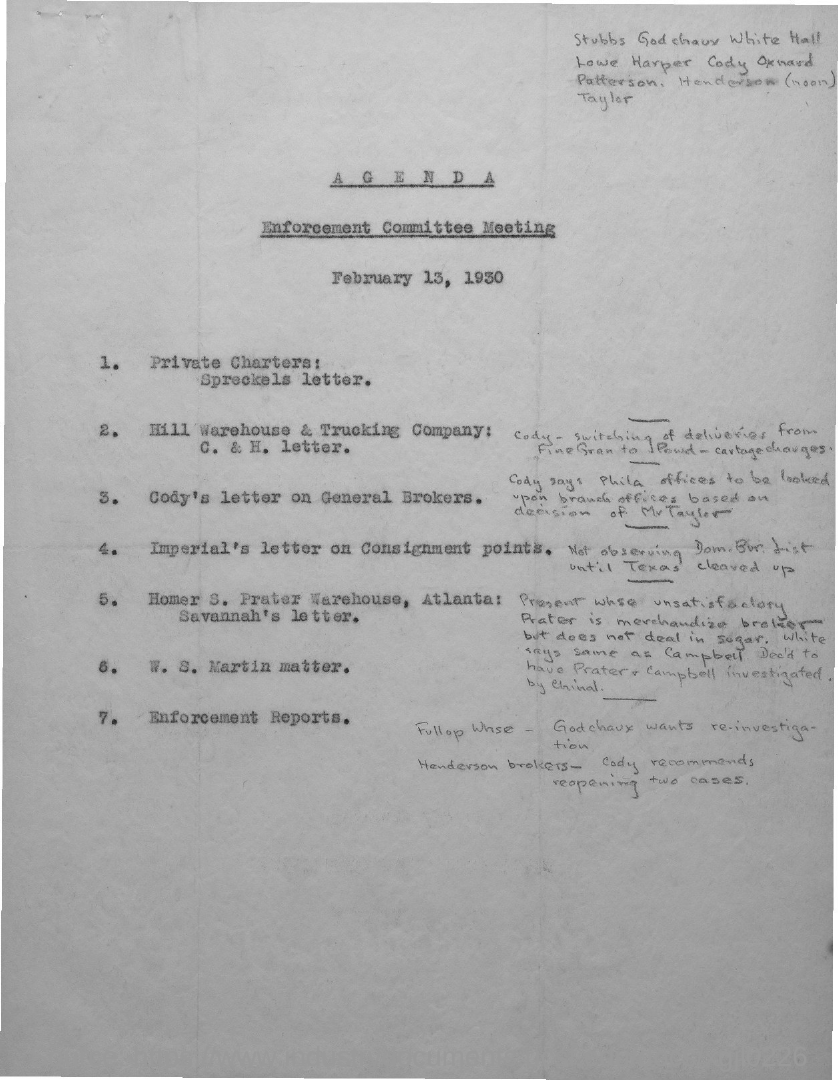Point out several critical features in this image. The enforcement committee meeting will be held according to the agenda on February 13, 1930. 